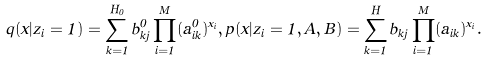Convert formula to latex. <formula><loc_0><loc_0><loc_500><loc_500>q ( x | z _ { i } = 1 ) = \sum _ { k = 1 } ^ { H _ { 0 } } b ^ { 0 } _ { k j } \prod _ { i = 1 } ^ { M } ( a ^ { 0 } _ { i k } ) ^ { x _ { i } } , p ( x | z _ { i } = 1 , A , B ) = \sum _ { k = 1 } ^ { H } b _ { k j } \prod _ { i = 1 } ^ { M } ( a _ { i k } ) ^ { x _ { i } } .</formula> 